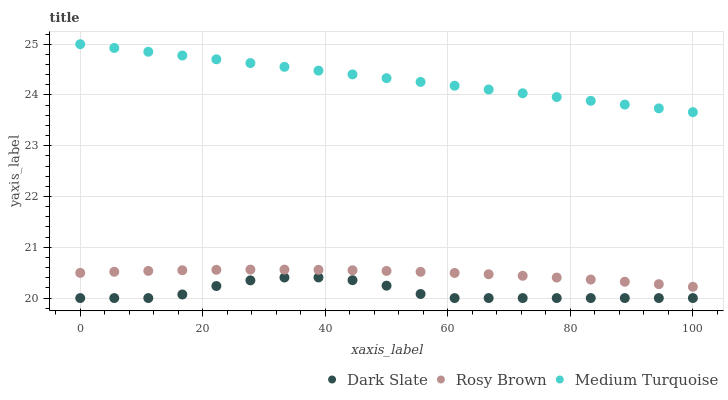Does Dark Slate have the minimum area under the curve?
Answer yes or no. Yes. Does Medium Turquoise have the maximum area under the curve?
Answer yes or no. Yes. Does Rosy Brown have the minimum area under the curve?
Answer yes or no. No. Does Rosy Brown have the maximum area under the curve?
Answer yes or no. No. Is Medium Turquoise the smoothest?
Answer yes or no. Yes. Is Dark Slate the roughest?
Answer yes or no. Yes. Is Rosy Brown the smoothest?
Answer yes or no. No. Is Rosy Brown the roughest?
Answer yes or no. No. Does Dark Slate have the lowest value?
Answer yes or no. Yes. Does Rosy Brown have the lowest value?
Answer yes or no. No. Does Medium Turquoise have the highest value?
Answer yes or no. Yes. Does Rosy Brown have the highest value?
Answer yes or no. No. Is Dark Slate less than Medium Turquoise?
Answer yes or no. Yes. Is Rosy Brown greater than Dark Slate?
Answer yes or no. Yes. Does Dark Slate intersect Medium Turquoise?
Answer yes or no. No. 